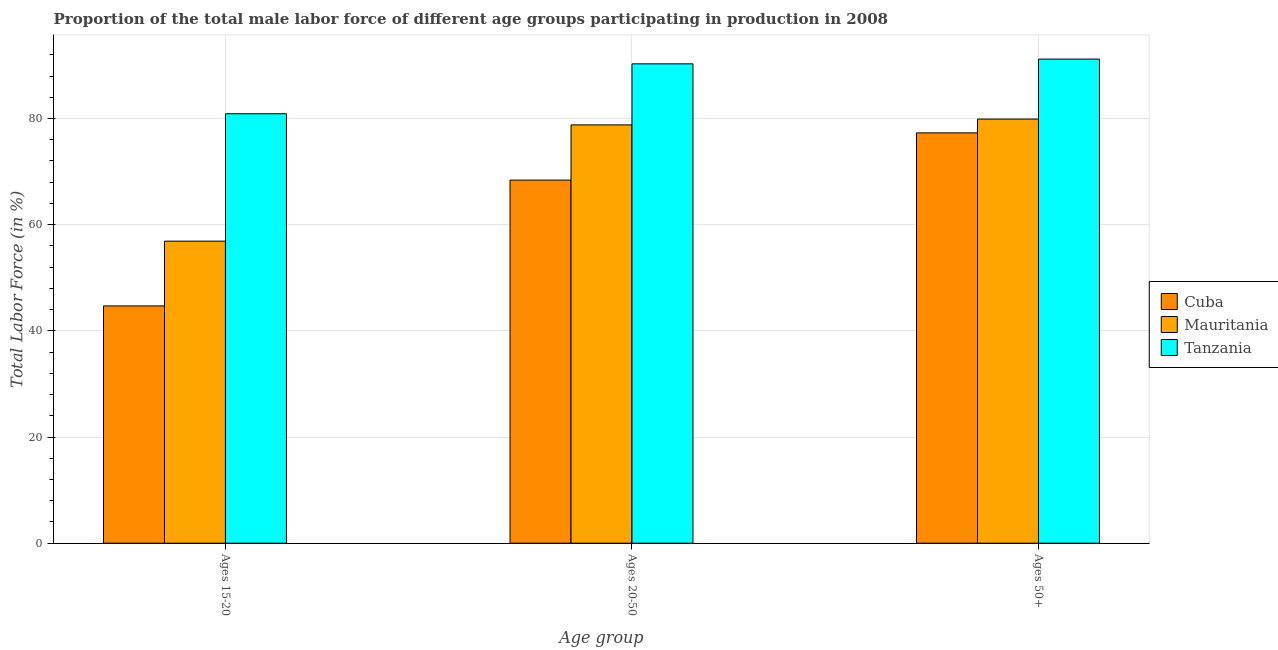How many groups of bars are there?
Give a very brief answer. 3. What is the label of the 3rd group of bars from the left?
Your response must be concise. Ages 50+. What is the percentage of male labor force within the age group 15-20 in Mauritania?
Give a very brief answer. 56.9. Across all countries, what is the maximum percentage of male labor force within the age group 20-50?
Make the answer very short. 90.3. Across all countries, what is the minimum percentage of male labor force within the age group 20-50?
Your answer should be compact. 68.4. In which country was the percentage of male labor force within the age group 15-20 maximum?
Offer a very short reply. Tanzania. In which country was the percentage of male labor force within the age group 15-20 minimum?
Offer a very short reply. Cuba. What is the total percentage of male labor force within the age group 20-50 in the graph?
Offer a very short reply. 237.5. What is the difference between the percentage of male labor force within the age group 20-50 in Cuba and that in Tanzania?
Give a very brief answer. -21.9. What is the difference between the percentage of male labor force above age 50 in Cuba and the percentage of male labor force within the age group 15-20 in Tanzania?
Give a very brief answer. -3.6. What is the average percentage of male labor force within the age group 20-50 per country?
Provide a short and direct response. 79.17. What is the difference between the percentage of male labor force within the age group 15-20 and percentage of male labor force within the age group 20-50 in Cuba?
Offer a terse response. -23.7. In how many countries, is the percentage of male labor force within the age group 20-50 greater than 16 %?
Give a very brief answer. 3. What is the ratio of the percentage of male labor force within the age group 20-50 in Cuba to that in Tanzania?
Offer a very short reply. 0.76. Is the difference between the percentage of male labor force within the age group 15-20 in Tanzania and Mauritania greater than the difference between the percentage of male labor force within the age group 20-50 in Tanzania and Mauritania?
Keep it short and to the point. Yes. What is the difference between the highest and the second highest percentage of male labor force within the age group 20-50?
Your answer should be very brief. 11.5. What is the difference between the highest and the lowest percentage of male labor force above age 50?
Make the answer very short. 13.9. In how many countries, is the percentage of male labor force within the age group 20-50 greater than the average percentage of male labor force within the age group 20-50 taken over all countries?
Offer a very short reply. 1. Is the sum of the percentage of male labor force above age 50 in Tanzania and Cuba greater than the maximum percentage of male labor force within the age group 20-50 across all countries?
Give a very brief answer. Yes. What does the 1st bar from the left in Ages 50+ represents?
Keep it short and to the point. Cuba. What does the 1st bar from the right in Ages 20-50 represents?
Give a very brief answer. Tanzania. How many bars are there?
Provide a succinct answer. 9. How many countries are there in the graph?
Your answer should be compact. 3. What is the difference between two consecutive major ticks on the Y-axis?
Offer a terse response. 20. Are the values on the major ticks of Y-axis written in scientific E-notation?
Ensure brevity in your answer.  No. Does the graph contain grids?
Offer a terse response. Yes. Where does the legend appear in the graph?
Offer a very short reply. Center right. How many legend labels are there?
Offer a terse response. 3. What is the title of the graph?
Your response must be concise. Proportion of the total male labor force of different age groups participating in production in 2008. Does "Dominica" appear as one of the legend labels in the graph?
Your answer should be very brief. No. What is the label or title of the X-axis?
Give a very brief answer. Age group. What is the label or title of the Y-axis?
Make the answer very short. Total Labor Force (in %). What is the Total Labor Force (in %) of Cuba in Ages 15-20?
Make the answer very short. 44.7. What is the Total Labor Force (in %) of Mauritania in Ages 15-20?
Your answer should be very brief. 56.9. What is the Total Labor Force (in %) of Tanzania in Ages 15-20?
Your answer should be compact. 80.9. What is the Total Labor Force (in %) of Cuba in Ages 20-50?
Your response must be concise. 68.4. What is the Total Labor Force (in %) in Mauritania in Ages 20-50?
Your answer should be compact. 78.8. What is the Total Labor Force (in %) of Tanzania in Ages 20-50?
Make the answer very short. 90.3. What is the Total Labor Force (in %) of Cuba in Ages 50+?
Your response must be concise. 77.3. What is the Total Labor Force (in %) in Mauritania in Ages 50+?
Your response must be concise. 79.9. What is the Total Labor Force (in %) of Tanzania in Ages 50+?
Give a very brief answer. 91.2. Across all Age group, what is the maximum Total Labor Force (in %) in Cuba?
Ensure brevity in your answer.  77.3. Across all Age group, what is the maximum Total Labor Force (in %) of Mauritania?
Give a very brief answer. 79.9. Across all Age group, what is the maximum Total Labor Force (in %) in Tanzania?
Give a very brief answer. 91.2. Across all Age group, what is the minimum Total Labor Force (in %) of Cuba?
Give a very brief answer. 44.7. Across all Age group, what is the minimum Total Labor Force (in %) of Mauritania?
Provide a short and direct response. 56.9. Across all Age group, what is the minimum Total Labor Force (in %) in Tanzania?
Make the answer very short. 80.9. What is the total Total Labor Force (in %) in Cuba in the graph?
Provide a short and direct response. 190.4. What is the total Total Labor Force (in %) of Mauritania in the graph?
Your answer should be very brief. 215.6. What is the total Total Labor Force (in %) of Tanzania in the graph?
Your answer should be very brief. 262.4. What is the difference between the Total Labor Force (in %) in Cuba in Ages 15-20 and that in Ages 20-50?
Offer a terse response. -23.7. What is the difference between the Total Labor Force (in %) of Mauritania in Ages 15-20 and that in Ages 20-50?
Provide a succinct answer. -21.9. What is the difference between the Total Labor Force (in %) in Cuba in Ages 15-20 and that in Ages 50+?
Keep it short and to the point. -32.6. What is the difference between the Total Labor Force (in %) of Mauritania in Ages 15-20 and that in Ages 50+?
Your answer should be compact. -23. What is the difference between the Total Labor Force (in %) of Cuba in Ages 20-50 and that in Ages 50+?
Keep it short and to the point. -8.9. What is the difference between the Total Labor Force (in %) in Tanzania in Ages 20-50 and that in Ages 50+?
Offer a terse response. -0.9. What is the difference between the Total Labor Force (in %) of Cuba in Ages 15-20 and the Total Labor Force (in %) of Mauritania in Ages 20-50?
Your answer should be very brief. -34.1. What is the difference between the Total Labor Force (in %) of Cuba in Ages 15-20 and the Total Labor Force (in %) of Tanzania in Ages 20-50?
Keep it short and to the point. -45.6. What is the difference between the Total Labor Force (in %) of Mauritania in Ages 15-20 and the Total Labor Force (in %) of Tanzania in Ages 20-50?
Offer a terse response. -33.4. What is the difference between the Total Labor Force (in %) of Cuba in Ages 15-20 and the Total Labor Force (in %) of Mauritania in Ages 50+?
Provide a short and direct response. -35.2. What is the difference between the Total Labor Force (in %) in Cuba in Ages 15-20 and the Total Labor Force (in %) in Tanzania in Ages 50+?
Ensure brevity in your answer.  -46.5. What is the difference between the Total Labor Force (in %) in Mauritania in Ages 15-20 and the Total Labor Force (in %) in Tanzania in Ages 50+?
Your response must be concise. -34.3. What is the difference between the Total Labor Force (in %) of Cuba in Ages 20-50 and the Total Labor Force (in %) of Tanzania in Ages 50+?
Give a very brief answer. -22.8. What is the average Total Labor Force (in %) in Cuba per Age group?
Your response must be concise. 63.47. What is the average Total Labor Force (in %) in Mauritania per Age group?
Provide a short and direct response. 71.87. What is the average Total Labor Force (in %) in Tanzania per Age group?
Offer a very short reply. 87.47. What is the difference between the Total Labor Force (in %) of Cuba and Total Labor Force (in %) of Mauritania in Ages 15-20?
Keep it short and to the point. -12.2. What is the difference between the Total Labor Force (in %) of Cuba and Total Labor Force (in %) of Tanzania in Ages 15-20?
Keep it short and to the point. -36.2. What is the difference between the Total Labor Force (in %) in Mauritania and Total Labor Force (in %) in Tanzania in Ages 15-20?
Offer a very short reply. -24. What is the difference between the Total Labor Force (in %) of Cuba and Total Labor Force (in %) of Tanzania in Ages 20-50?
Your answer should be compact. -21.9. What is the difference between the Total Labor Force (in %) in Cuba and Total Labor Force (in %) in Mauritania in Ages 50+?
Provide a short and direct response. -2.6. What is the difference between the Total Labor Force (in %) in Cuba and Total Labor Force (in %) in Tanzania in Ages 50+?
Offer a very short reply. -13.9. What is the ratio of the Total Labor Force (in %) in Cuba in Ages 15-20 to that in Ages 20-50?
Offer a terse response. 0.65. What is the ratio of the Total Labor Force (in %) in Mauritania in Ages 15-20 to that in Ages 20-50?
Keep it short and to the point. 0.72. What is the ratio of the Total Labor Force (in %) of Tanzania in Ages 15-20 to that in Ages 20-50?
Your response must be concise. 0.9. What is the ratio of the Total Labor Force (in %) in Cuba in Ages 15-20 to that in Ages 50+?
Offer a terse response. 0.58. What is the ratio of the Total Labor Force (in %) of Mauritania in Ages 15-20 to that in Ages 50+?
Make the answer very short. 0.71. What is the ratio of the Total Labor Force (in %) of Tanzania in Ages 15-20 to that in Ages 50+?
Offer a very short reply. 0.89. What is the ratio of the Total Labor Force (in %) of Cuba in Ages 20-50 to that in Ages 50+?
Your answer should be compact. 0.88. What is the ratio of the Total Labor Force (in %) in Mauritania in Ages 20-50 to that in Ages 50+?
Keep it short and to the point. 0.99. What is the difference between the highest and the second highest Total Labor Force (in %) of Cuba?
Make the answer very short. 8.9. What is the difference between the highest and the lowest Total Labor Force (in %) in Cuba?
Your answer should be compact. 32.6. What is the difference between the highest and the lowest Total Labor Force (in %) in Mauritania?
Make the answer very short. 23. 